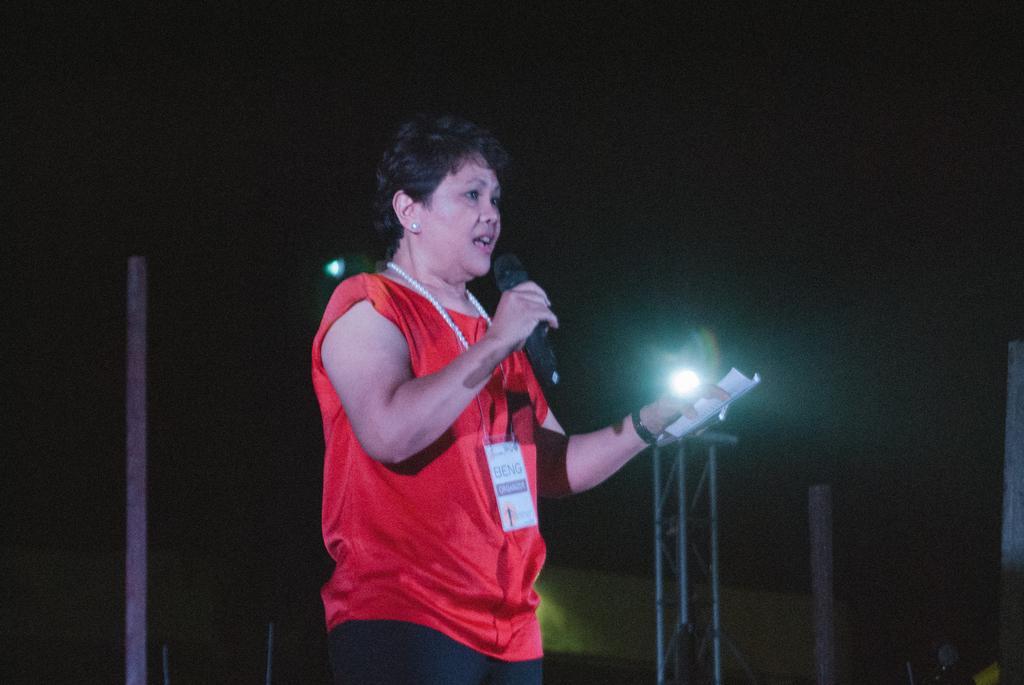Describe this image in one or two sentences. In this picture I can observe a woman in the middle of the picture. She is holding a mic in her hand. The background is dark. 